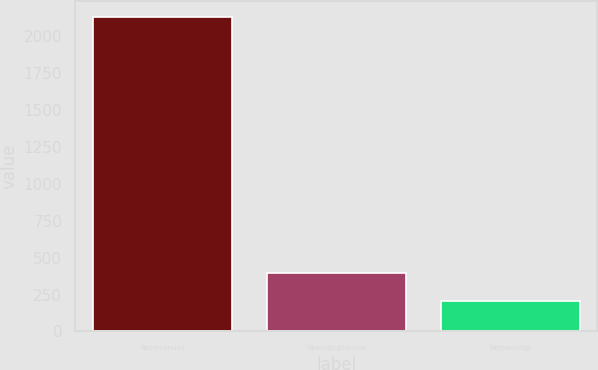Convert chart to OTSL. <chart><loc_0><loc_0><loc_500><loc_500><bar_chart><fcel>Netrevenues<fcel>Operatingincome<fcel>Netearnings<nl><fcel>2128<fcel>397.39<fcel>205.1<nl></chart> 